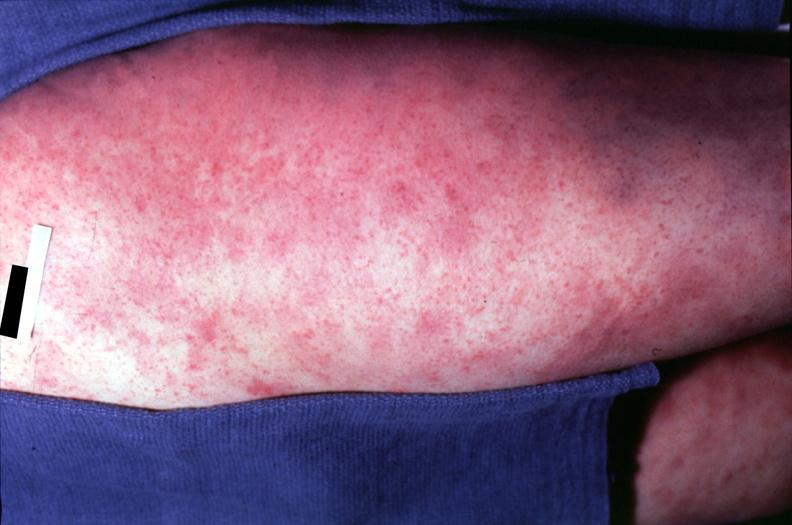s rocky mountain spotted fever, morbilliform rash?
Answer the question using a single word or phrase. Yes 